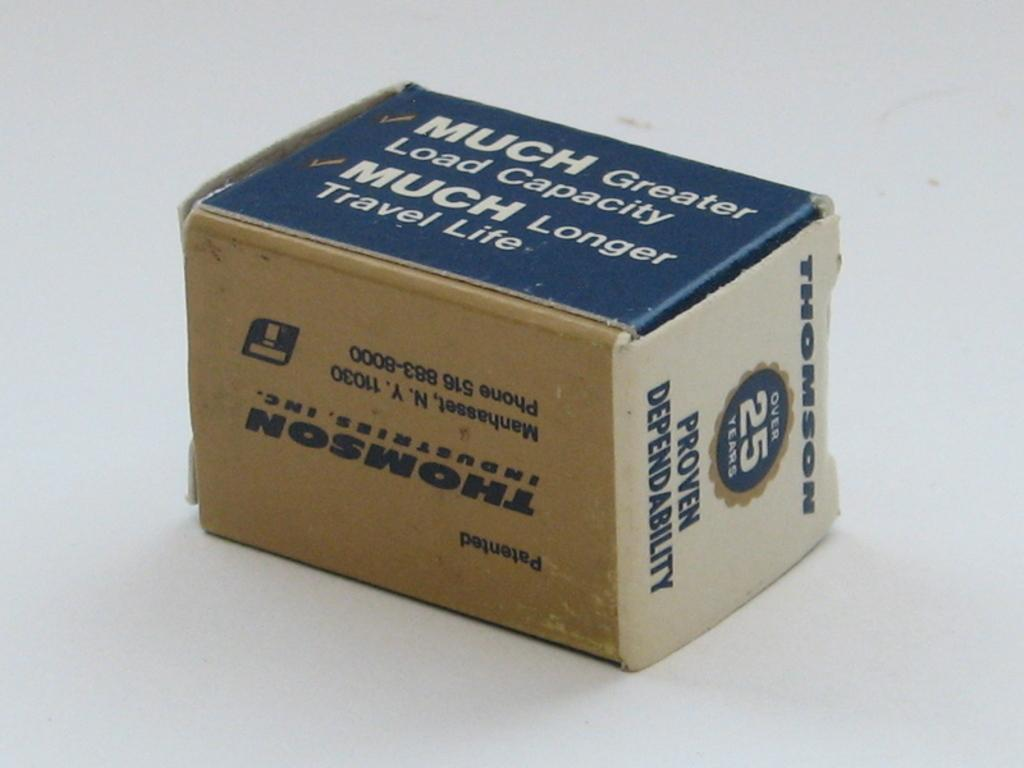Provide a one-sentence caption for the provided image. Thompson Industries swears that its products have proven dependability. 